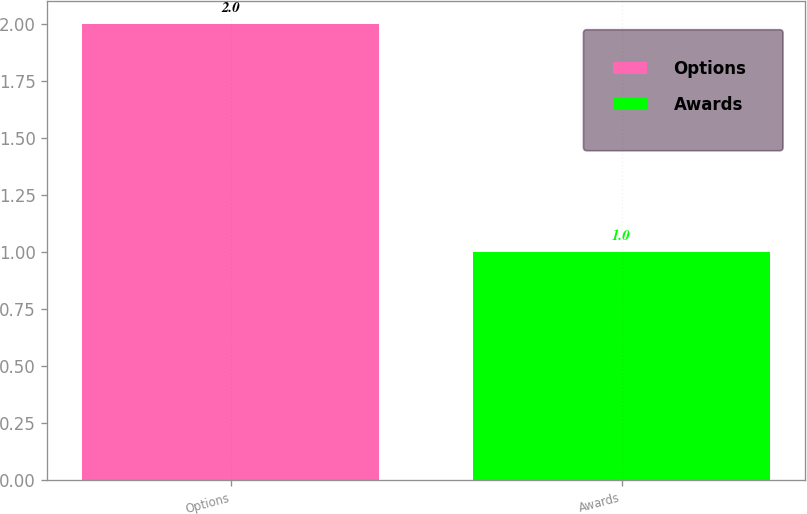Convert chart. <chart><loc_0><loc_0><loc_500><loc_500><bar_chart><fcel>Options<fcel>Awards<nl><fcel>2<fcel>1<nl></chart> 